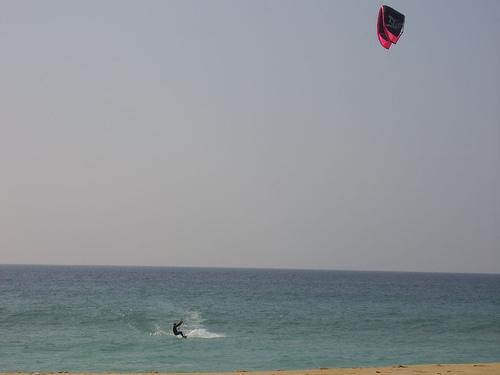What color is the kite?
Keep it brief. Red and black. How many people are there?
Concise answer only. 1. Is this person wet or dry?
Answer briefly. Wet. Is the person indoors?
Be succinct. No. How many people are surfing?
Write a very short answer. 1. What is the woman doing?
Concise answer only. Kitesurfing. Is there a ship on the horizon?
Give a very brief answer. No. Is it wavy?
Answer briefly. No. What is the little object in the water?
Write a very short answer. Person. Is it a sunny day out?
Write a very short answer. No. What is the man riding?
Short answer required. Surfboard. How many people are in the water?
Be succinct. 1. How many ocean waves are in this photo?
Write a very short answer. 0. Why are they wearing wetsuits?
Be succinct. It's cold. 